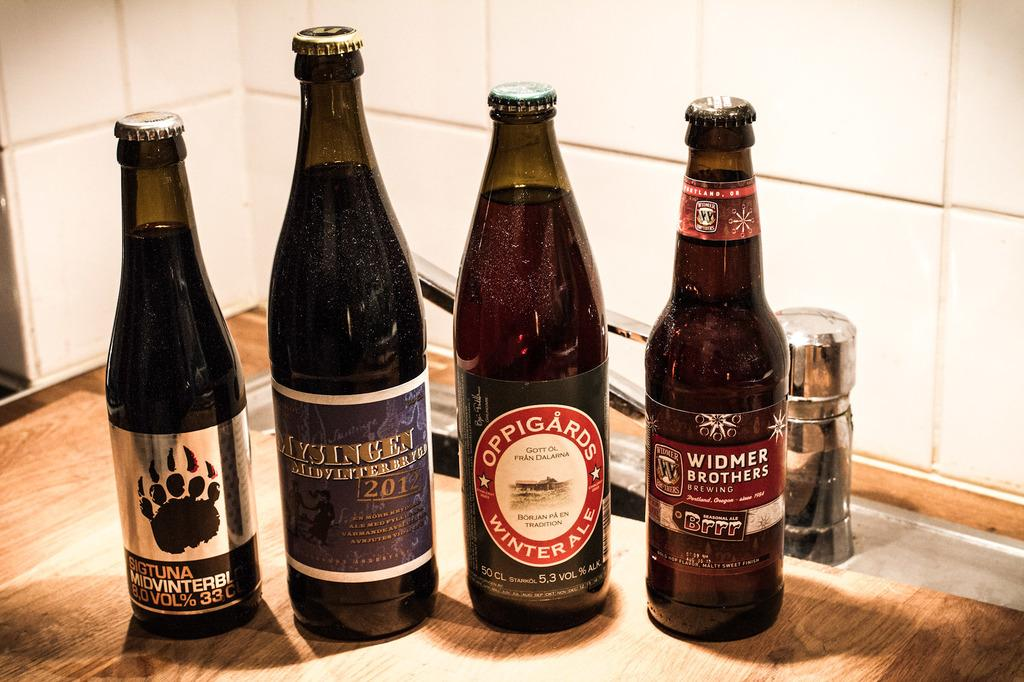<image>
Give a short and clear explanation of the subsequent image. A bottle of Widmer Brothers beer sits next to three other brands of beer. 